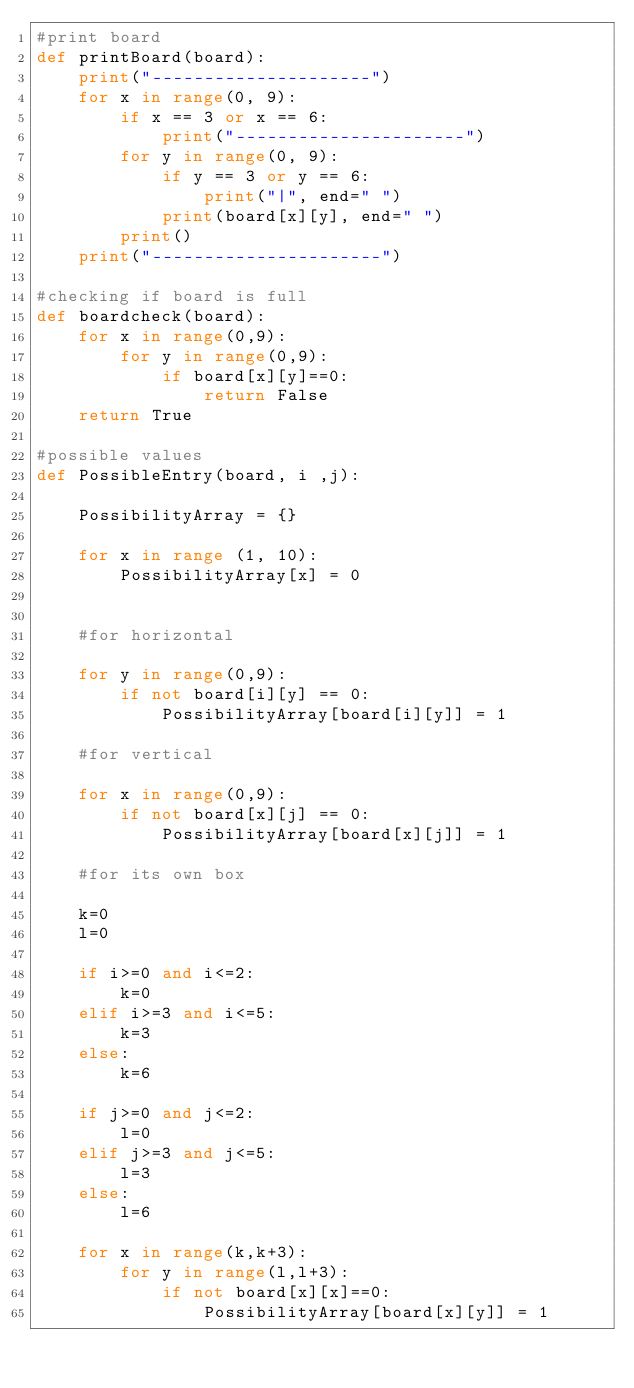Convert code to text. <code><loc_0><loc_0><loc_500><loc_500><_Python_>#print board
def printBoard(board):
    print("---------------------")
    for x in range(0, 9):
        if x == 3 or x == 6:
            print("----------------------")
        for y in range(0, 9):
            if y == 3 or y == 6:
                print("|", end=" ")
            print(board[x][y], end=" ")
        print()
    print("----------------------")

#checking if board is full
def boardcheck(board):
    for x in range(0,9):
        for y in range(0,9):
            if board[x][y]==0:
                return False
    return True

#possible values
def PossibleEntry(board, i ,j):

    PossibilityArray = {}

    for x in range (1, 10):
        PossibilityArray[x] = 0
    

    #for horizontal

    for y in range(0,9):
        if not board[i][y] == 0:
            PossibilityArray[board[i][y]] = 1

    #for vertical

    for x in range(0,9):
        if not board[x][j] == 0:
            PossibilityArray[board[x][j]] = 1

    #for its own box

    k=0
    l=0

    if i>=0 and i<=2:
        k=0
    elif i>=3 and i<=5:
        k=3
    else:
        k=6

    if j>=0 and j<=2:
        l=0
    elif j>=3 and j<=5:
        l=3
    else:
        l=6

    for x in range(k,k+3):
        for y in range(l,l+3):
            if not board[x][x]==0:
                PossibilityArray[board[x][y]] = 1
    </code> 